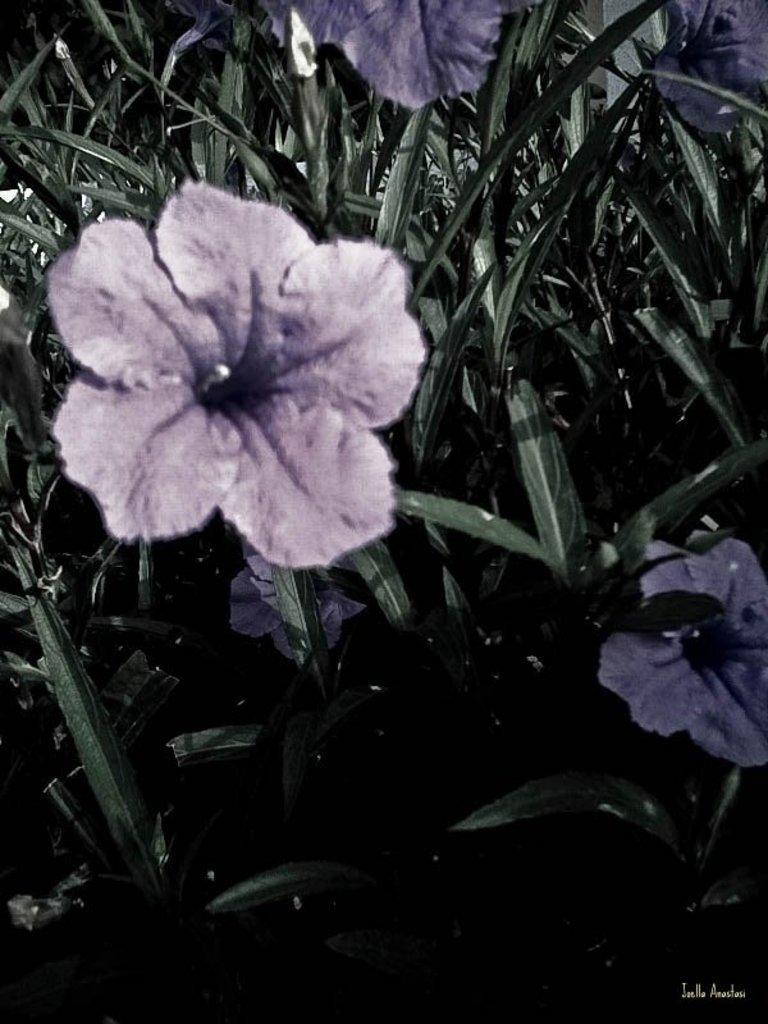Can you describe this image briefly? In this picture I can see there are few plants and there is a purple flower, leaves. 